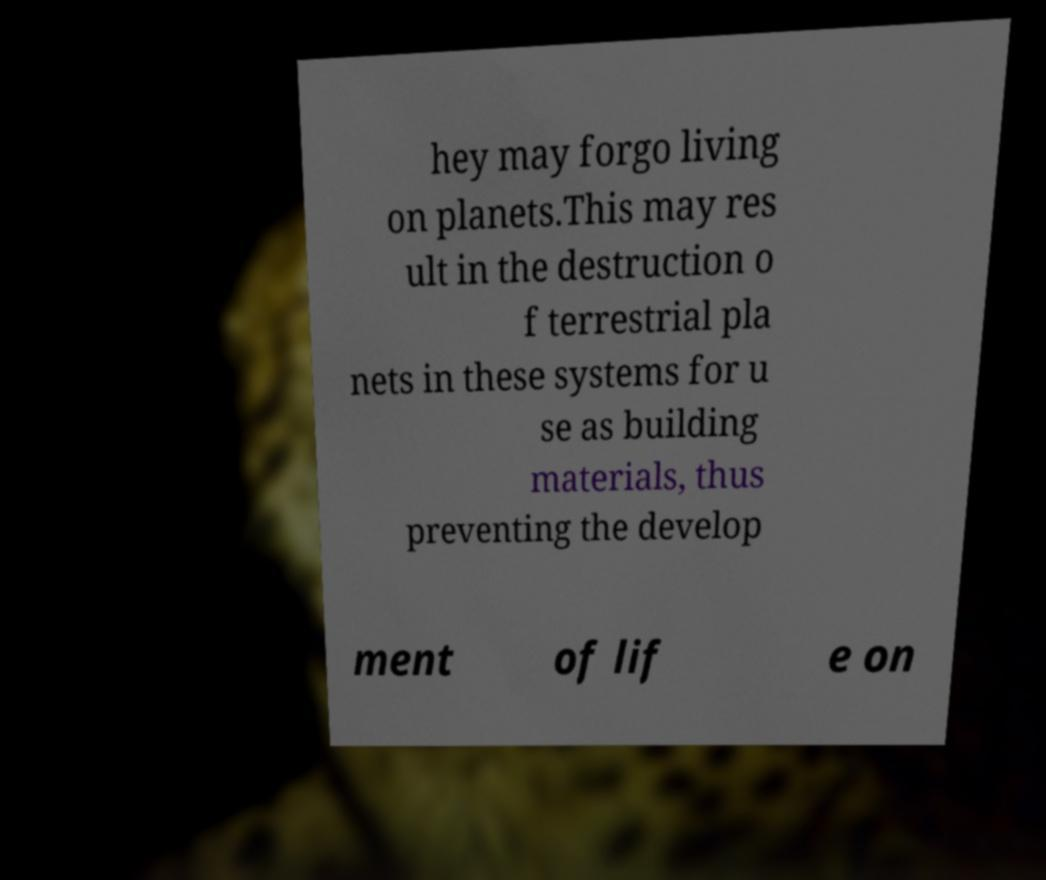Could you extract and type out the text from this image? hey may forgo living on planets.This may res ult in the destruction o f terrestrial pla nets in these systems for u se as building materials, thus preventing the develop ment of lif e on 